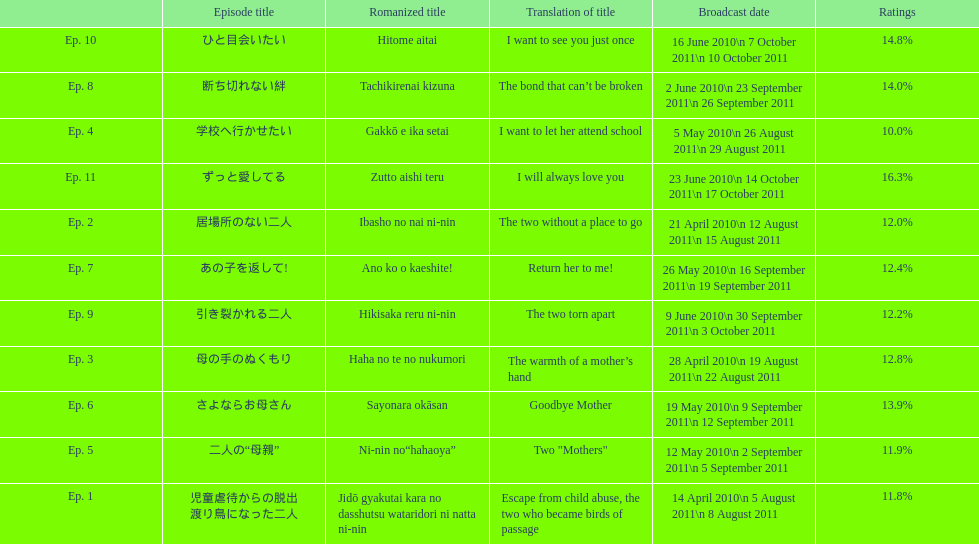What is the total number of episodes listed? 11. 